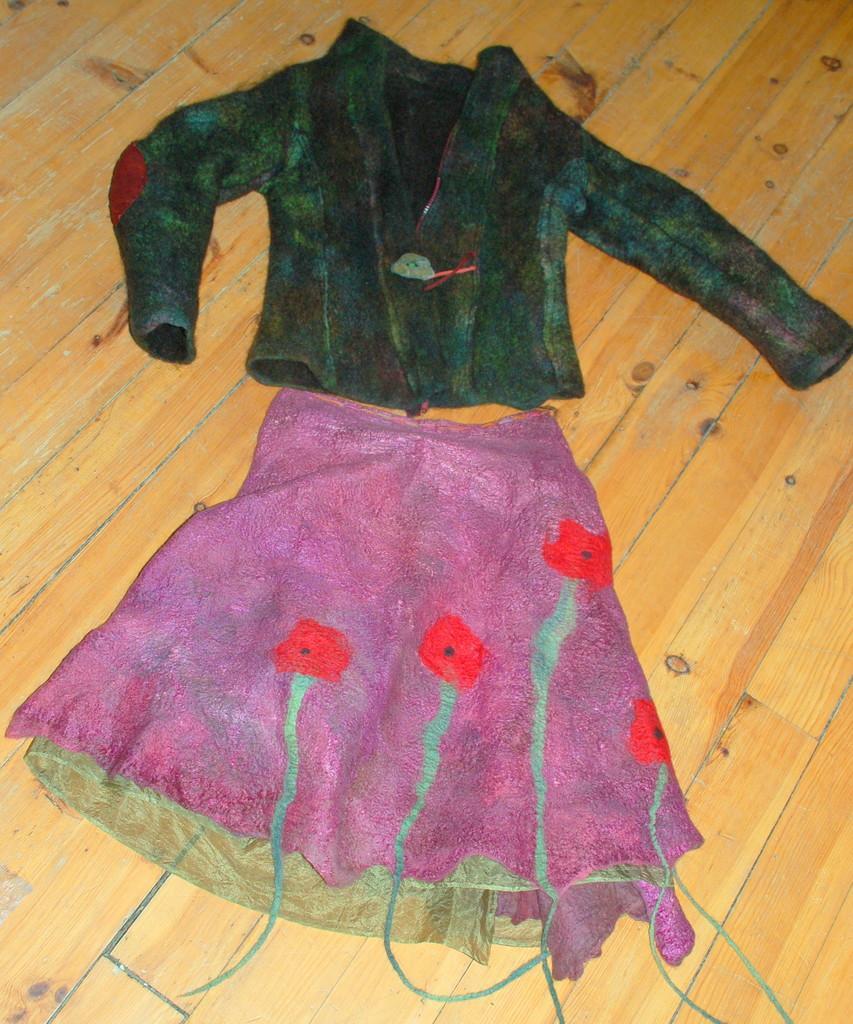Please provide a concise description of this image. In this image I can see the dress on the brown color surface and the dress is in green and pink color. 